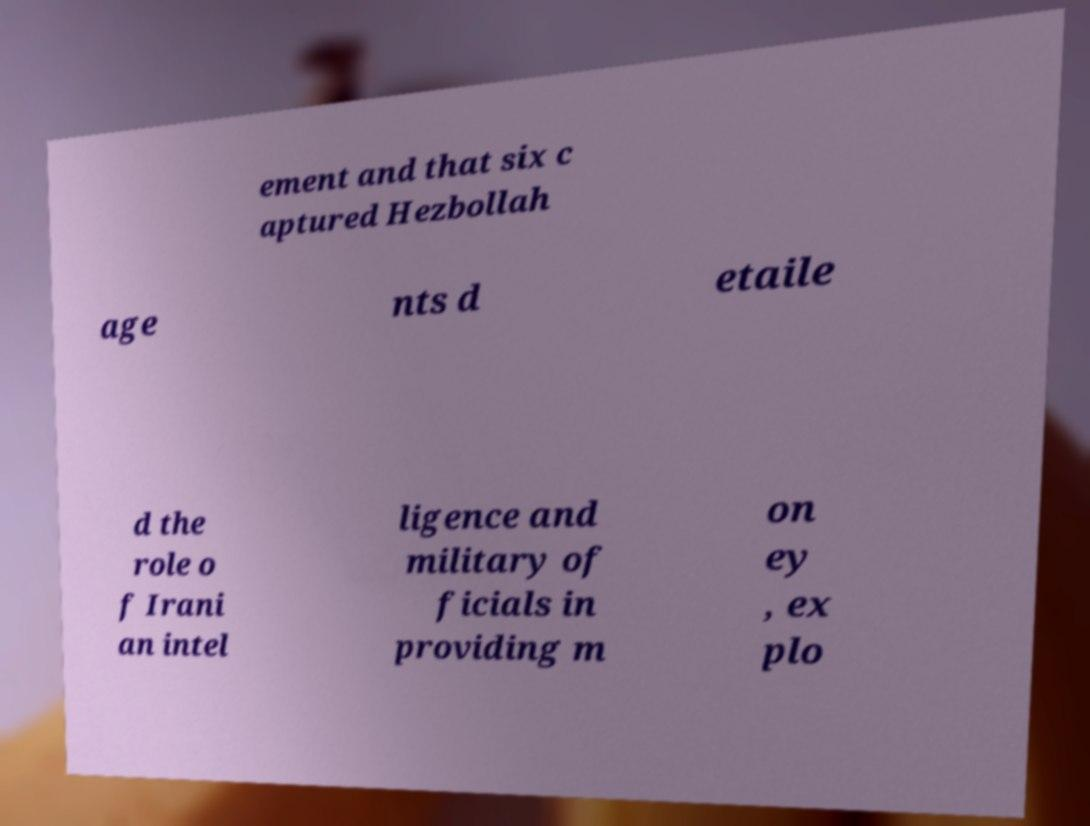There's text embedded in this image that I need extracted. Can you transcribe it verbatim? ement and that six c aptured Hezbollah age nts d etaile d the role o f Irani an intel ligence and military of ficials in providing m on ey , ex plo 